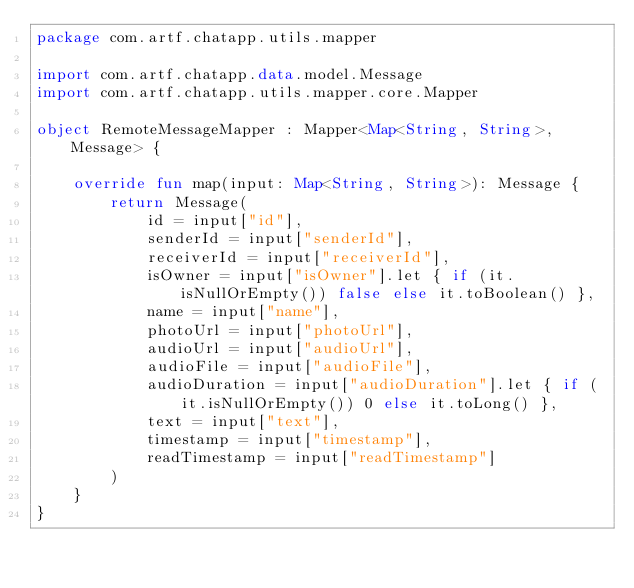Convert code to text. <code><loc_0><loc_0><loc_500><loc_500><_Kotlin_>package com.artf.chatapp.utils.mapper

import com.artf.chatapp.data.model.Message
import com.artf.chatapp.utils.mapper.core.Mapper

object RemoteMessageMapper : Mapper<Map<String, String>, Message> {

    override fun map(input: Map<String, String>): Message {
        return Message(
            id = input["id"],
            senderId = input["senderId"],
            receiverId = input["receiverId"],
            isOwner = input["isOwner"].let { if (it.isNullOrEmpty()) false else it.toBoolean() },
            name = input["name"],
            photoUrl = input["photoUrl"],
            audioUrl = input["audioUrl"],
            audioFile = input["audioFile"],
            audioDuration = input["audioDuration"].let { if (it.isNullOrEmpty()) 0 else it.toLong() },
            text = input["text"],
            timestamp = input["timestamp"],
            readTimestamp = input["readTimestamp"]
        )
    }
}</code> 